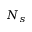Convert formula to latex. <formula><loc_0><loc_0><loc_500><loc_500>N _ { s }</formula> 